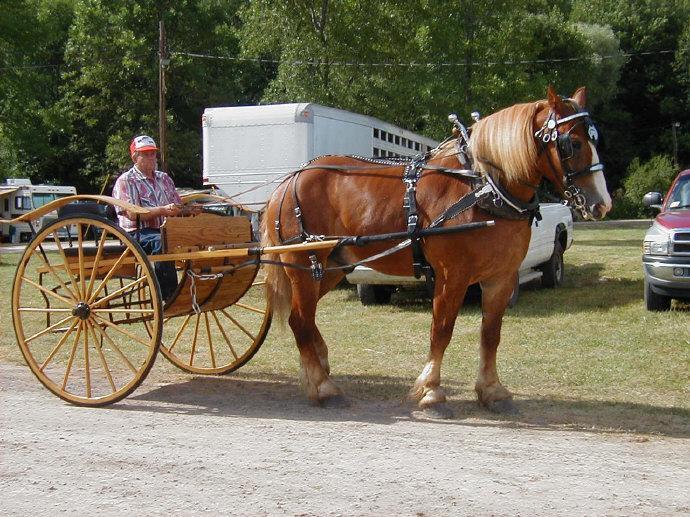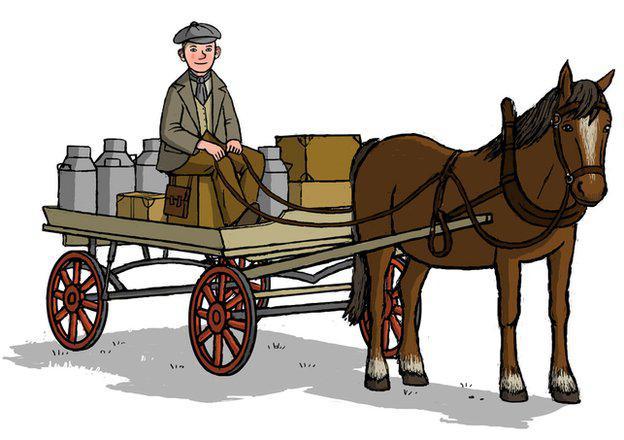The first image is the image on the left, the second image is the image on the right. Assess this claim about the two images: "All the carriages are facing left.". Correct or not? Answer yes or no. No. 